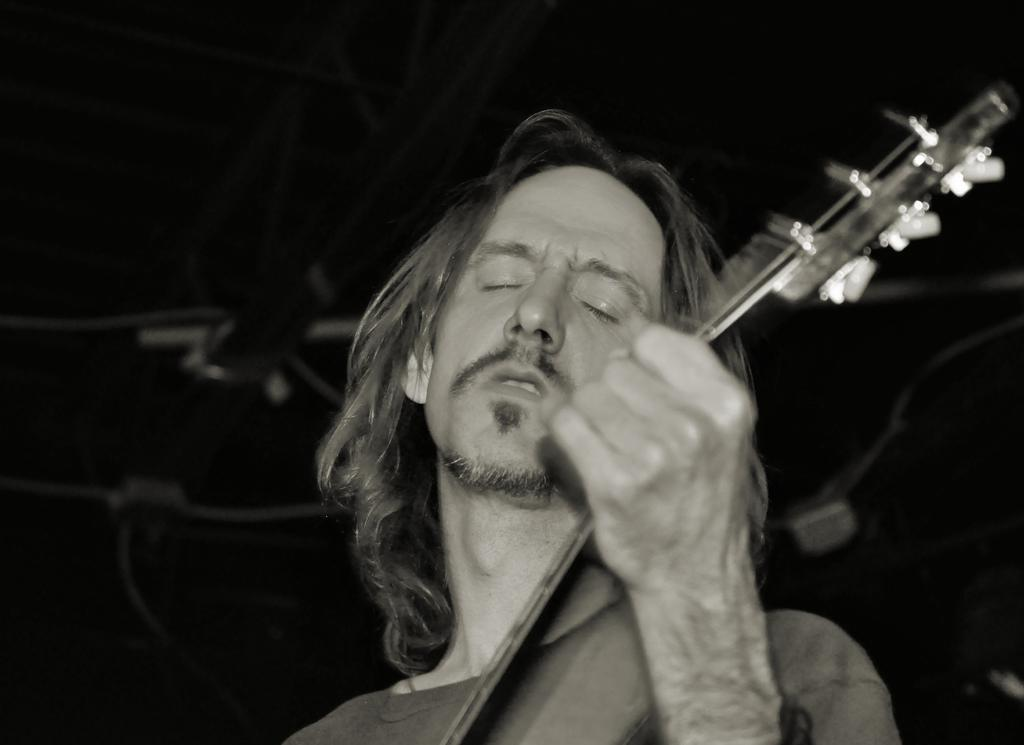Who is the main subject in the image? There is a man in the image. Can you describe the man's appearance? The man has short hair. What is the man holding in the image? The man is holding a guitar. Where is the man positioned in the image? The man is standing in the middle of the image. How many kittens are playing with the man's guitar in the image? There are no kittens present in the image, so it is not possible to determine how many would be playing with the guitar. 